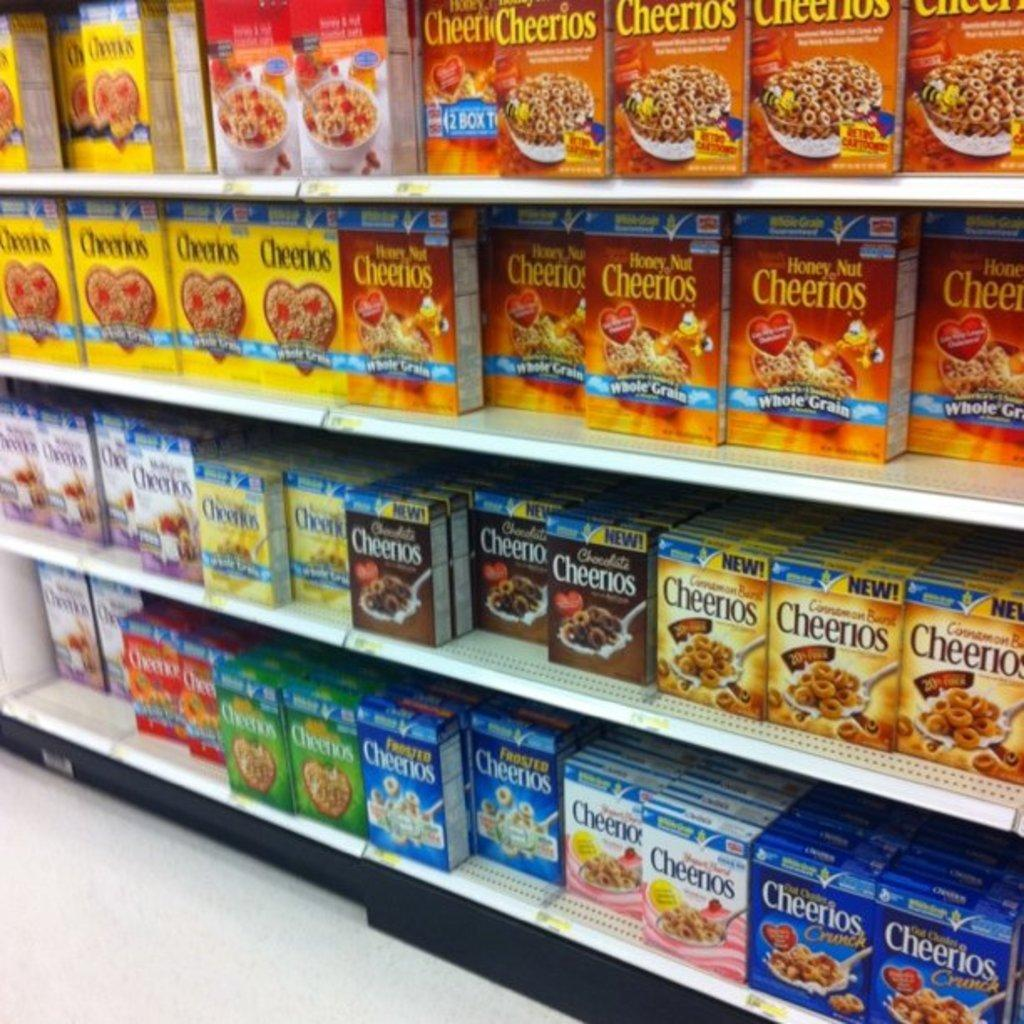<image>
Present a compact description of the photo's key features. Boxes of different flavors of Cheerios on the shelves. 